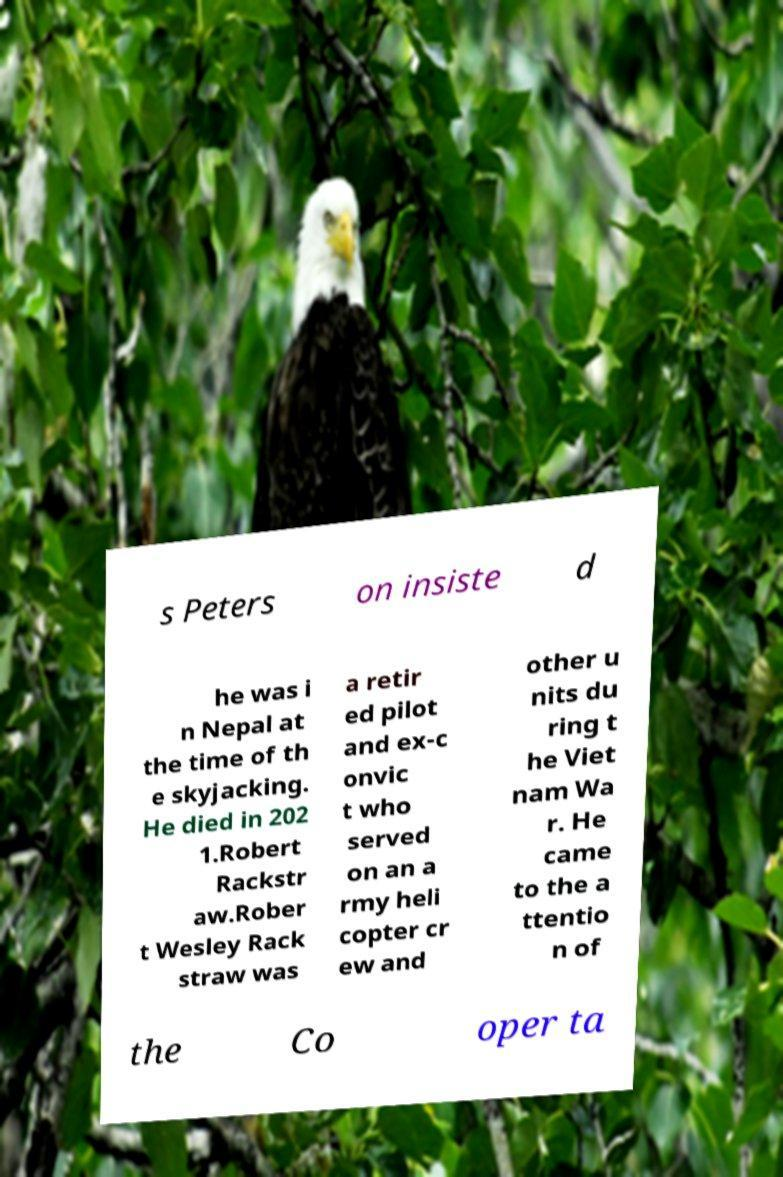Please read and relay the text visible in this image. What does it say? s Peters on insiste d he was i n Nepal at the time of th e skyjacking. He died in 202 1.Robert Rackstr aw.Rober t Wesley Rack straw was a retir ed pilot and ex-c onvic t who served on an a rmy heli copter cr ew and other u nits du ring t he Viet nam Wa r. He came to the a ttentio n of the Co oper ta 